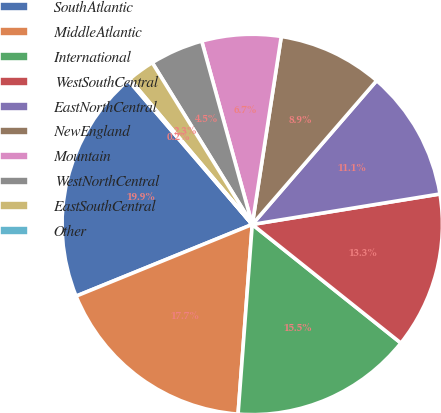Convert chart to OTSL. <chart><loc_0><loc_0><loc_500><loc_500><pie_chart><fcel>SouthAtlantic<fcel>MiddleAtlantic<fcel>International<fcel>WestSouthCentral<fcel>EastNorthCentral<fcel>NewEngland<fcel>Mountain<fcel>WestNorthCentral<fcel>EastSouthCentral<fcel>Other<nl><fcel>19.85%<fcel>17.66%<fcel>15.47%<fcel>13.28%<fcel>11.09%<fcel>8.91%<fcel>6.72%<fcel>4.53%<fcel>2.34%<fcel>0.15%<nl></chart> 